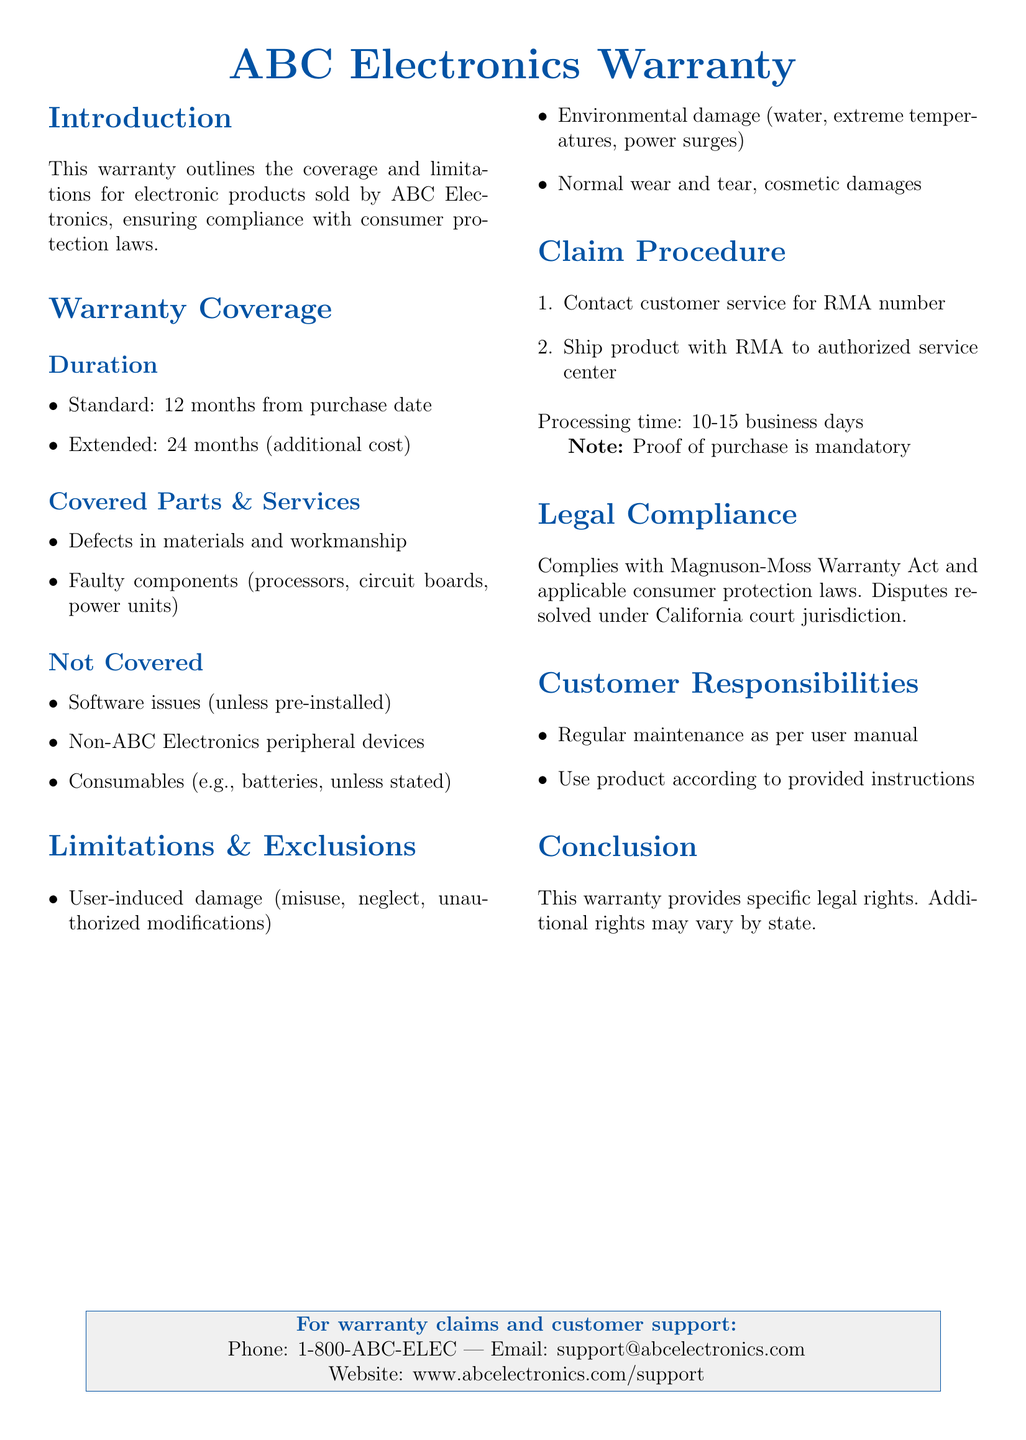what is the standard warranty duration? The standard warranty duration is specified in the warranty coverage section.
Answer: 12 months how long is the extended warranty? The document explicitly states the duration of the extended warranty in the coverage section.
Answer: 24 months what types of components are covered under the warranty? The covered parts and services section lists specific components.
Answer: Defects in materials and workmanship, faulty components which items are not covered by the warranty? The document itemizes exclusions in the warranty for clarity.
Answer: Software issues, non-ABC Electronics peripheral devices, consumables what is the processing time for warranty claims? The claim procedure section provides information on processing time.
Answer: 10-15 business days what must be provided to process a warranty claim? The claim procedure section mentions a specific requirement for claims.
Answer: Proof of purchase what legal act does this warranty comply with? The legal compliance section specifies the relevant legal act.
Answer: Magnuson-Moss Warranty Act what kind of damage is excluded from the warranty? The limitations and exclusions section details types of damages not covered.
Answer: User-induced damage, environmental damage, normal wear and tear what is one customer responsibility mentioned in the document? The customer responsibilities section outlines specific duties of the consumer.
Answer: Regular maintenance as per user manual 